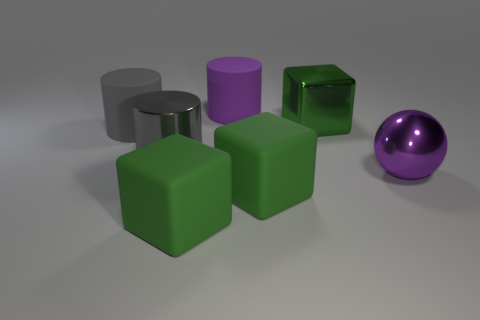What number of large metal objects are both in front of the green shiny object and on the right side of the gray metallic thing?
Provide a short and direct response. 1. There is a big purple thing that is right of the purple object that is on the left side of the metal ball; what is it made of?
Your response must be concise. Metal. There is a big purple thing that is the same shape as the large gray matte object; what is it made of?
Provide a succinct answer. Rubber. Are there any big brown matte blocks?
Ensure brevity in your answer.  No. What shape is the big green object that is the same material as the sphere?
Provide a succinct answer. Cube. What material is the large ball right of the purple matte thing?
Your response must be concise. Metal. Does the cube that is behind the shiny ball have the same color as the metal sphere?
Make the answer very short. No. There is a gray cylinder that is in front of the gray thing on the left side of the gray shiny object; how big is it?
Offer a terse response. Large. Is the number of cubes to the right of the large metal cube greater than the number of tiny green matte objects?
Ensure brevity in your answer.  No. Is the size of the purple object behind the green shiny block the same as the green shiny thing?
Your response must be concise. Yes. 